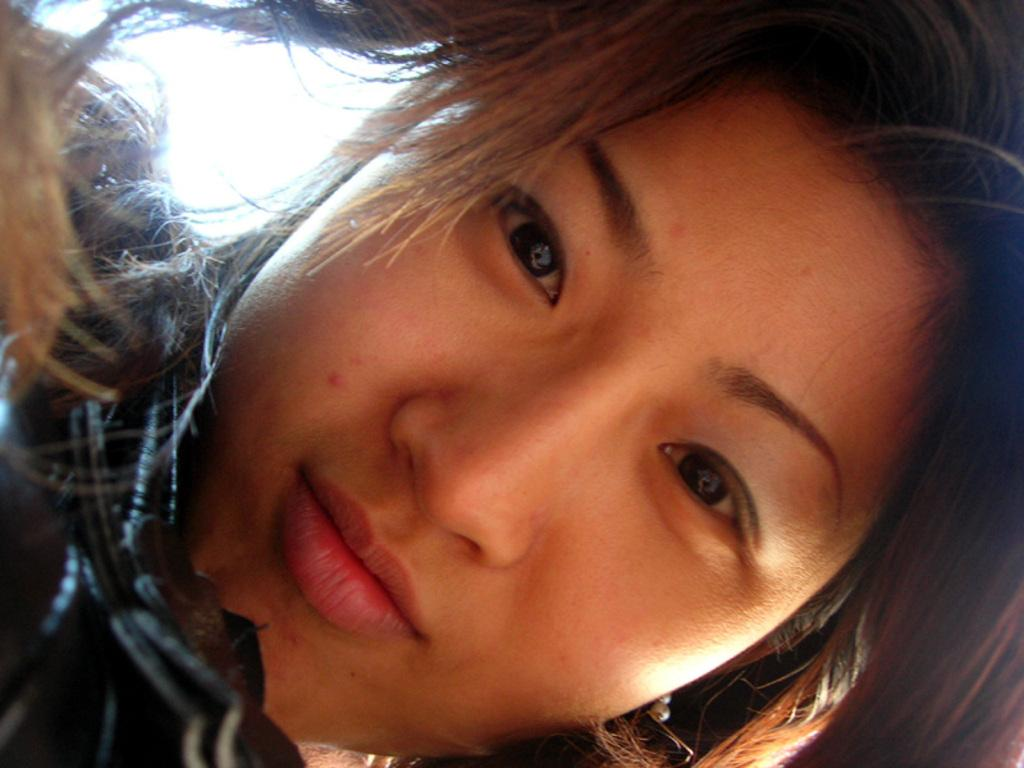What is present in the image? There is a person in the image. Can you describe the person's clothing? The person is wearing a shirt. Are there any fairies visible in the image? No, there are no fairies present in the image. What type of pin is the person using to hold the shirt together? There is no pin mentioned or visible in the image. 